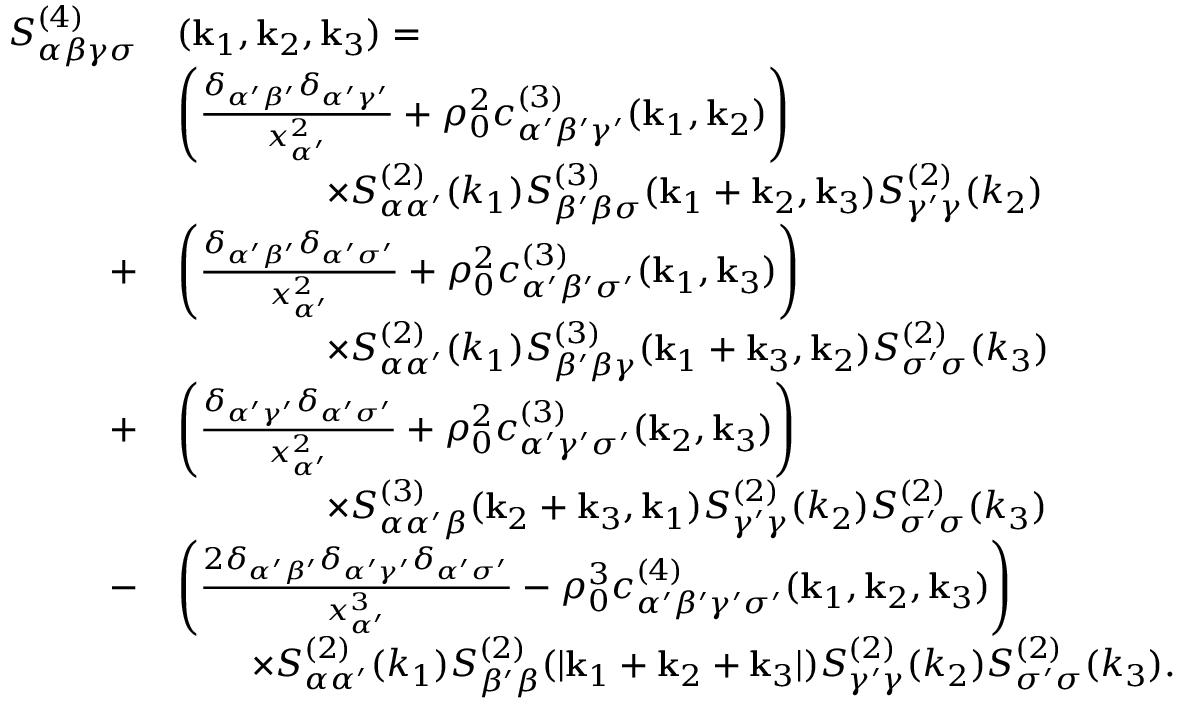<formula> <loc_0><loc_0><loc_500><loc_500>\begin{array} { r l } { S _ { \alpha \beta \gamma \sigma } ^ { ( 4 ) } } & { ( k _ { 1 } , k _ { 2 } , k _ { 3 } ) = } \\ & { \left ( \frac { \delta _ { \alpha ^ { \prime } \beta ^ { \prime } } \delta _ { \alpha ^ { \prime } \gamma ^ { \prime } } } { x _ { \alpha ^ { \prime } } ^ { 2 } } + \rho _ { 0 } ^ { 2 } c _ { \alpha ^ { \prime } \beta ^ { \prime } \gamma ^ { \prime } } ^ { ( 3 ) } ( k _ { 1 } , k _ { 2 } ) \right ) } \\ & { \quad \times S _ { \alpha \alpha ^ { \prime } } ^ { ( 2 ) } ( k _ { 1 } ) S _ { \beta ^ { \prime } \beta \sigma } ^ { ( 3 ) } ( k _ { 1 } + k _ { 2 } , k _ { 3 } ) S _ { \gamma ^ { \prime } \gamma } ^ { ( 2 ) } ( k _ { 2 } ) } \\ { + } & { \left ( \frac { \delta _ { \alpha ^ { \prime } \beta ^ { \prime } } \delta _ { \alpha ^ { \prime } \sigma ^ { \prime } } } { x _ { \alpha ^ { \prime } } ^ { 2 } } + \rho _ { 0 } ^ { 2 } c _ { \alpha ^ { \prime } \beta ^ { \prime } \sigma ^ { \prime } } ^ { ( 3 ) } ( k _ { 1 } , k _ { 3 } ) \right ) } \\ & { \quad \times S _ { \alpha \alpha ^ { \prime } } ^ { ( 2 ) } ( k _ { 1 } ) S _ { \beta ^ { \prime } \beta \gamma } ^ { ( 3 ) } ( k _ { 1 } + k _ { 3 } , k _ { 2 } ) S _ { \sigma ^ { \prime } \sigma } ^ { ( 2 ) } ( k _ { 3 } ) } \\ { + } & { \left ( \frac { \delta _ { \alpha ^ { \prime } \gamma ^ { \prime } } \delta _ { \alpha ^ { \prime } \sigma ^ { \prime } } } { x _ { \alpha ^ { \prime } } ^ { 2 } } + \rho _ { 0 } ^ { 2 } { c } _ { \alpha ^ { \prime } \gamma ^ { \prime } \sigma ^ { \prime } } ^ { ( 3 ) } ( k _ { 2 } , k _ { 3 } ) \right ) } \\ & { \quad \times S _ { \alpha \alpha ^ { \prime } \beta } ^ { ( 3 ) } ( k _ { 2 } + k _ { 3 } , k _ { 1 } ) S _ { \gamma ^ { \prime } \gamma } ^ { ( 2 ) } ( k _ { 2 } ) S _ { \sigma ^ { \prime } \sigma } ^ { ( 2 ) } ( k _ { 3 } ) } \\ { - } & { \left ( \frac { 2 \delta _ { \alpha ^ { \prime } \beta ^ { \prime } } \delta _ { \alpha ^ { \prime } \gamma ^ { \prime } } \delta _ { \alpha ^ { \prime } \sigma ^ { \prime } } } { x _ { \alpha ^ { \prime } } ^ { 3 } } - \rho _ { 0 } ^ { 3 } { c } _ { \alpha ^ { \prime } \beta ^ { \prime } \gamma ^ { \prime } \sigma ^ { \prime } } ^ { ( 4 ) } ( k _ { 1 } , k _ { 2 } , k _ { 3 } ) \right ) } \\ & { \quad \times S _ { \alpha \alpha ^ { \prime } } ^ { ( 2 ) } ( k _ { 1 } ) S _ { \beta ^ { \prime } \beta } ^ { ( 2 ) } ( | k _ { 1 } + k _ { 2 } + k _ { 3 } | ) S _ { \gamma ^ { \prime } \gamma } ^ { ( 2 ) } ( k _ { 2 } ) S _ { \sigma ^ { \prime } \sigma } ^ { ( 2 ) } ( k _ { 3 } ) . } \end{array}</formula> 